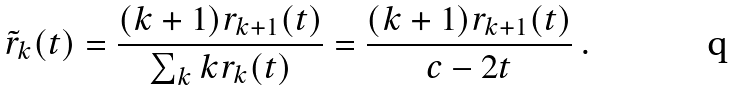Convert formula to latex. <formula><loc_0><loc_0><loc_500><loc_500>\tilde { r } _ { k } ( t ) = \frac { ( k + 1 ) r _ { k + 1 } ( t ) } { \sum _ { k } k r _ { k } ( t ) } = \frac { ( k + 1 ) r _ { k + 1 } ( t ) } { c - 2 t } \ .</formula> 